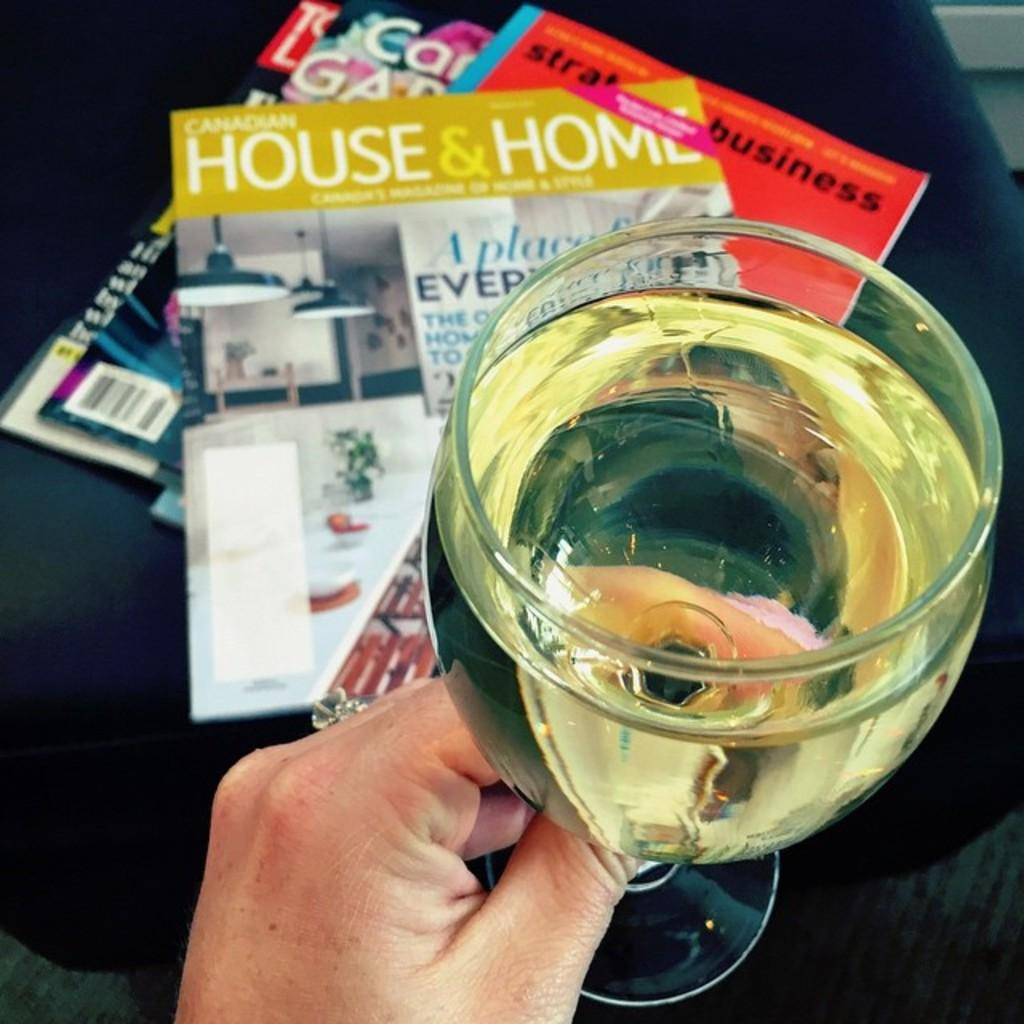<image>
Share a concise interpretation of the image provided. Someone is holding onto a glass of liquor with a HOUSE & HOME magazine (and others) in the background. 